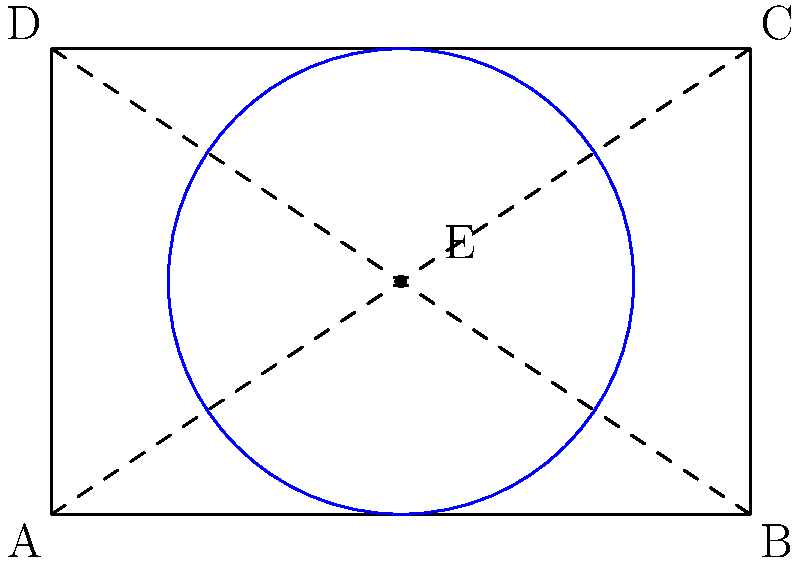A rectangular shelf unit measures 6 feet by 4 feet. To maximize floor space efficiency, you decide to rotate the unit around its center point. What is the minimum circular area needed to accommodate the shelf unit in all possible orientations? To solve this problem, we need to follow these steps:

1. Identify the center of rotation:
   The center of the rectangle is at the intersection of its diagonals, point E.

2. Determine the radius of the circular area:
   The radius will be half the length of the diagonal of the rectangle.

3. Calculate the length of the diagonal using the Pythagorean theorem:
   $$ diagonal^2 = 6^2 + 4^2 = 36 + 16 = 52 $$
   $$ diagonal = \sqrt{52} \approx 7.21 \text{ feet} $$

4. Calculate the radius:
   $$ radius = \frac{diagonal}{2} = \frac{\sqrt{52}}{2} \approx 3.61 \text{ feet} $$

5. Calculate the area of the circle:
   $$ A = \pi r^2 = \pi (\frac{\sqrt{52}}{2})^2 = \frac{52\pi}{4} = 13\pi \approx 40.84 \text{ square feet} $$

Therefore, the minimum circular area needed to accommodate the shelf unit in all possible orientations is $13\pi$ square feet or approximately 40.84 square feet.
Answer: $13\pi$ square feet 